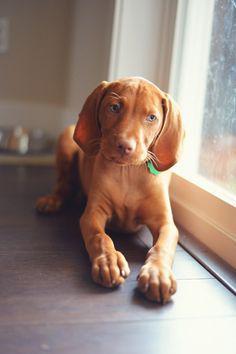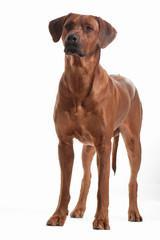The first image is the image on the left, the second image is the image on the right. For the images displayed, is the sentence "Each image contains a single red-orange dog, and the right image contains an upward-gazing dog in a sitting pose with a toy stuffed animal by one foot." factually correct? Answer yes or no. No. The first image is the image on the left, the second image is the image on the right. Assess this claim about the two images: "A Vizsla dog is lying on a blanket.". Correct or not? Answer yes or no. No. 